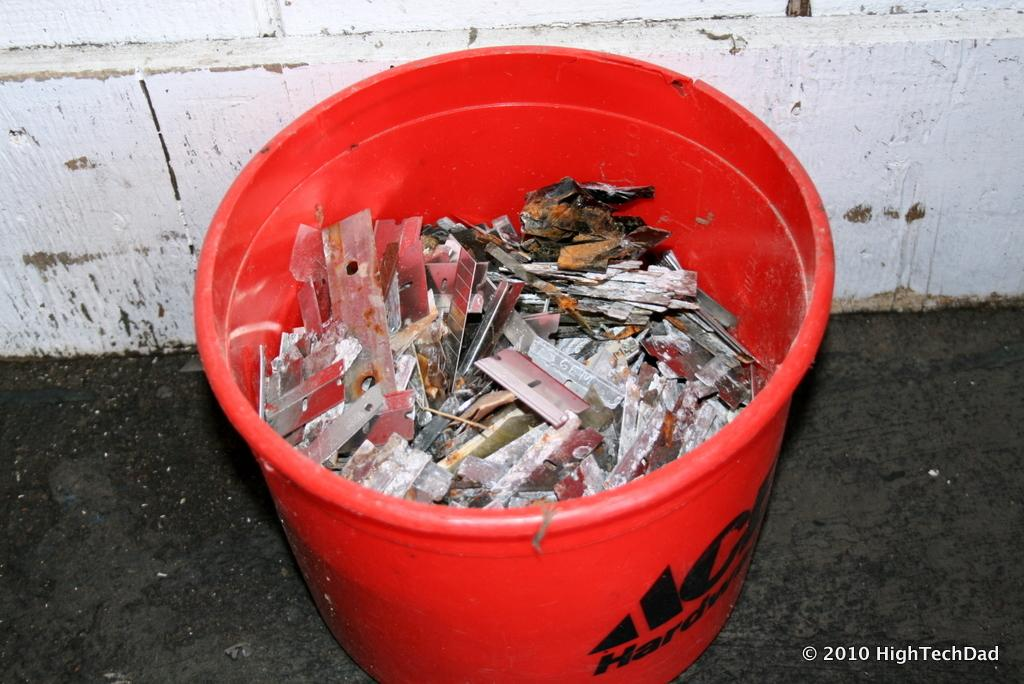<image>
Create a compact narrative representing the image presented. A red bucket from Ace Hardware is full of old used razor blades. 